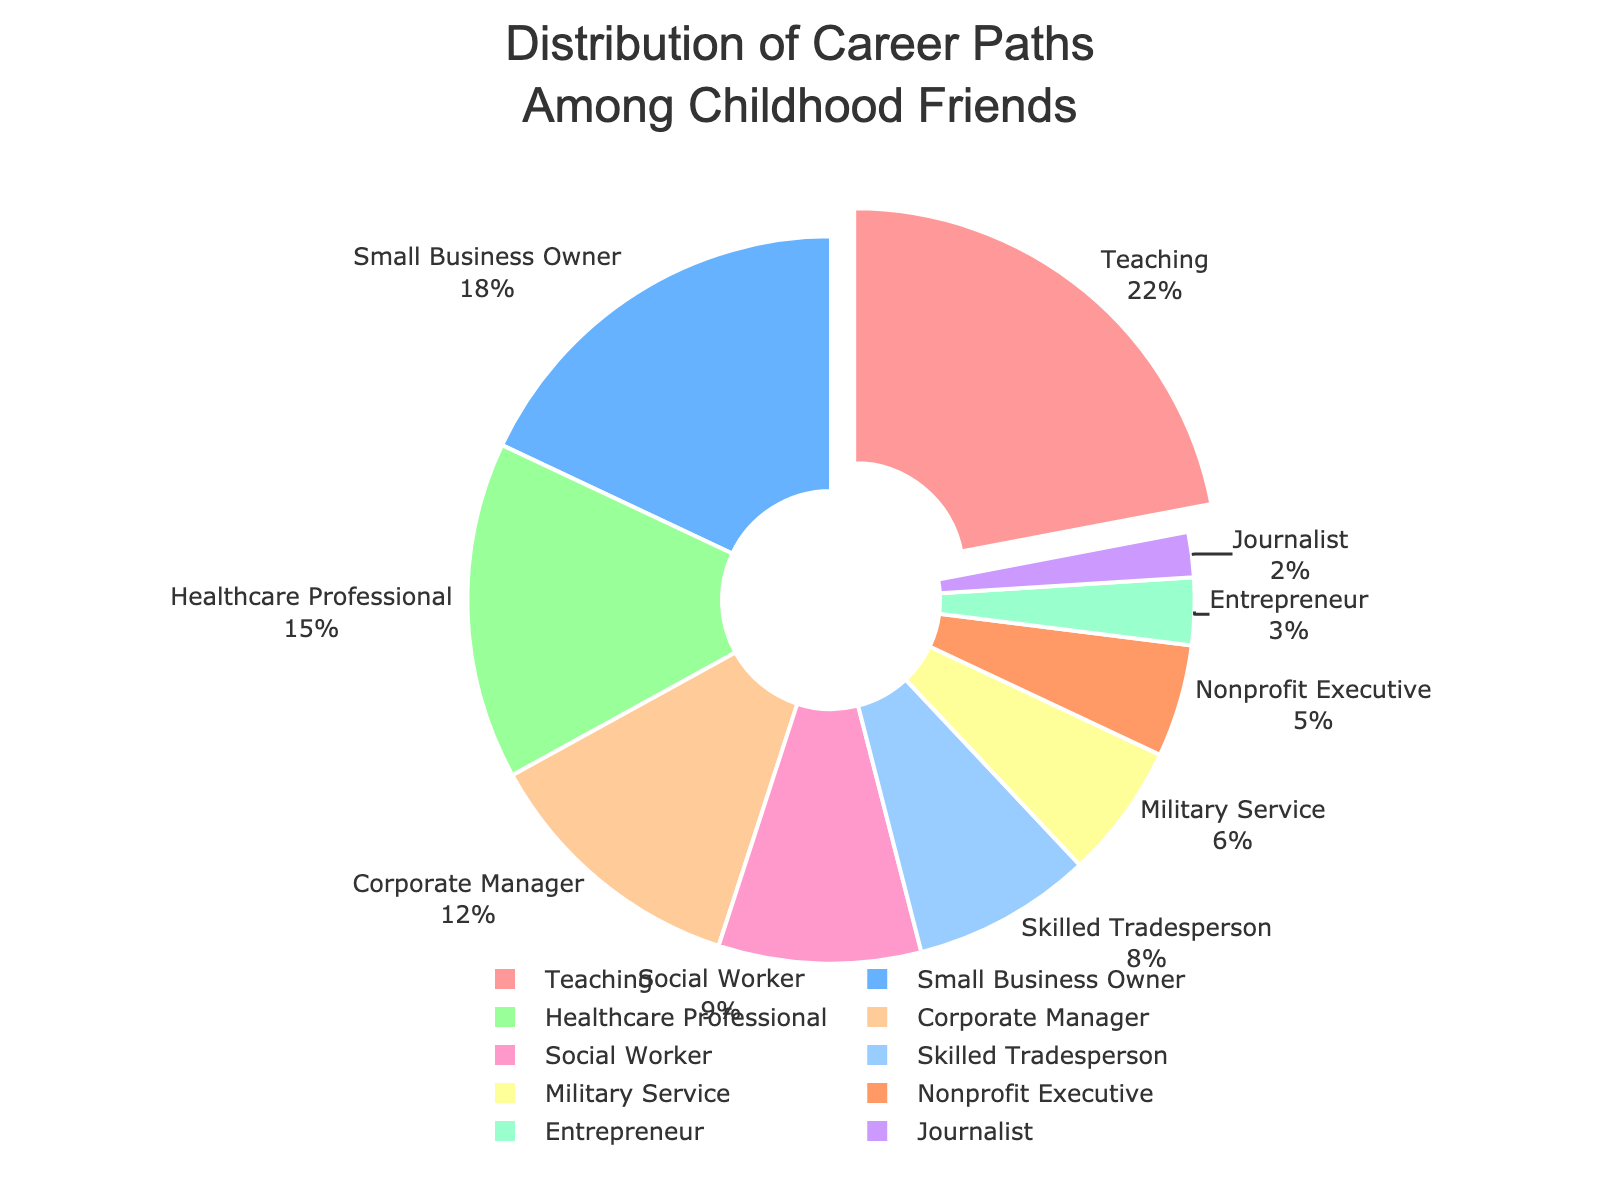Which career path is the most common among the group? The career path with the highest percentage in the pie chart is the most common. The "Teaching" sector has the largest slice at 22%.
Answer: Teaching What is the combined percentage of Healthcare Professionals and Social Workers? Add the percentages for Healthcare Professionals and Social Workers. Healthcare Professionals are at 15% and Social Workers are at 9%. So, 15 + 9 = 24%.
Answer: 24% Which career path has a larger share: Skilled Tradesperson or Nonprofit Executive? Compare the percentages for Skilled Tradesperson and Nonprofit Executive. Skilled Tradesperson has 8% while Nonprofit Executive has 5%, thus Skilled Tradesperson is larger.
Answer: Skilled Tradesperson If you add the percentages of Teaching, Small Business Owner, and Corporate Manager, how much is it? Add the percentages for Teaching, Small Business Owner, and Corporate Manager. Teaching is 22%, Small Business Owner is 18%, and Corporate Manager is 12%. So, 22 + 18 + 12 = 52%.
Answer: 52% Which career path is represented by the smallest slice in the pie chart? The smallest slice corresponds to the category with the smallest percentage, which is Journalist at 2%.
Answer: Journalist How does the size of the Entrepreneur slice compare to the Military Service slice? Compare the percentages for Entrepreneur and Military Service. Entrepreneur is at 3% while Military Service is at 6%. Therefore, Military Service is larger.
Answer: Military Service By how much does the percentage of Teaching exceed the percentage of Small Business Owner? Subtract the percentage of Small Business Owner from Teaching. Teaching is 22%, and Small Business Owner is 18%. So, 22 - 18 = 4%.
Answer: 4% Which slices are pulled out from the pie chart, and why? The slice that is pulled out is usually the largest one to emphasize its significance. The "Teaching" slice is pulled out since it has the highest percentage at 22%.
Answer: Teaching What is the total percentage of career paths other than Corporate Manager and Skilled Tradesperson? Subtract the sum of Corporate Manager and Skilled Tradesperson percentages from 100%. Corporate Manager is 12% and Skilled Tradesperson is 8%. So, 100 - (12 + 8) = 80%.
Answer: 80% If the slices are colored differently, which color represents Healthcare Professionals? By visually identifying the colors or using a legend if present. Healthcare Professionals are represented by the third largest slice at 15%, which is colored green in the pie chart.
Answer: Green 